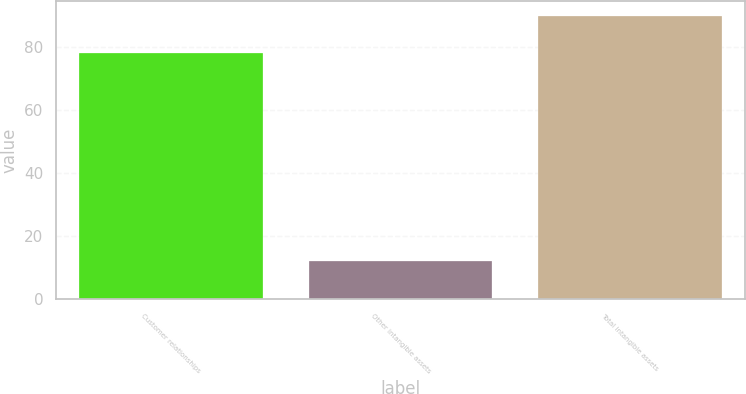Convert chart to OTSL. <chart><loc_0><loc_0><loc_500><loc_500><bar_chart><fcel>Customer relationships<fcel>Other intangible assets<fcel>Total intangible assets<nl><fcel>78<fcel>12<fcel>90<nl></chart> 